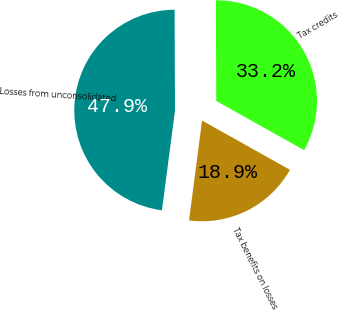Convert chart to OTSL. <chart><loc_0><loc_0><loc_500><loc_500><pie_chart><fcel>Losses from unconsolidated<fcel>Tax credits<fcel>Tax benefits on losses<nl><fcel>47.87%<fcel>33.19%<fcel>18.94%<nl></chart> 